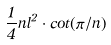Convert formula to latex. <formula><loc_0><loc_0><loc_500><loc_500>\frac { 1 } { 4 } n l ^ { 2 } \cdot c o t ( \pi / n )</formula> 